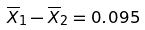Convert formula to latex. <formula><loc_0><loc_0><loc_500><loc_500>\overline { X } _ { 1 } - \overline { X } _ { 2 } = 0 . 0 9 5</formula> 